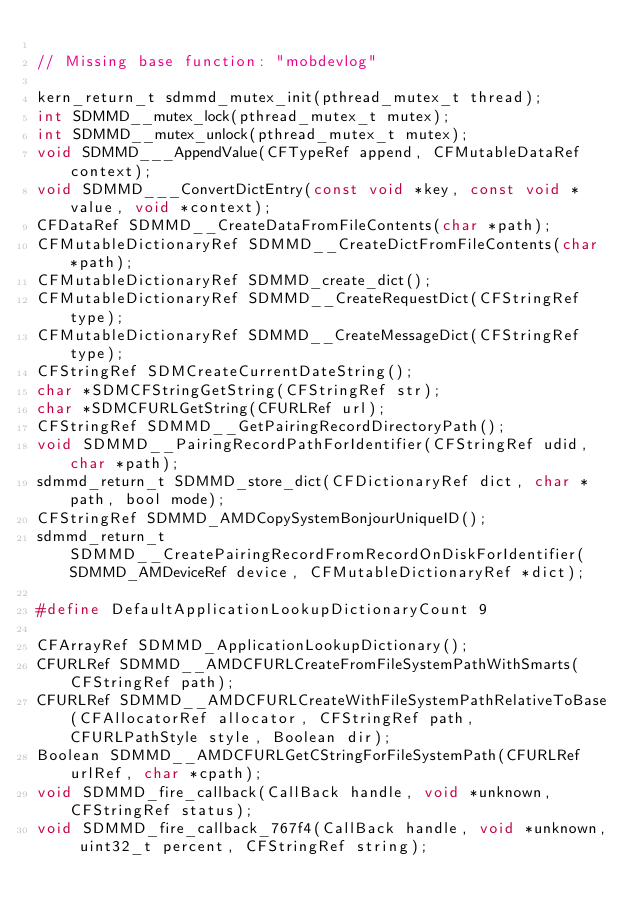<code> <loc_0><loc_0><loc_500><loc_500><_C_>
// Missing base function: "mobdevlog"

kern_return_t sdmmd_mutex_init(pthread_mutex_t thread);
int SDMMD__mutex_lock(pthread_mutex_t mutex);
int SDMMD__mutex_unlock(pthread_mutex_t mutex);
void SDMMD___AppendValue(CFTypeRef append, CFMutableDataRef context);
void SDMMD___ConvertDictEntry(const void *key, const void *value, void *context);
CFDataRef SDMMD__CreateDataFromFileContents(char *path);
CFMutableDictionaryRef SDMMD__CreateDictFromFileContents(char *path);
CFMutableDictionaryRef SDMMD_create_dict();
CFMutableDictionaryRef SDMMD__CreateRequestDict(CFStringRef type);
CFMutableDictionaryRef SDMMD__CreateMessageDict(CFStringRef type);
CFStringRef SDMCreateCurrentDateString();
char *SDMCFStringGetString(CFStringRef str);
char *SDMCFURLGetString(CFURLRef url);
CFStringRef SDMMD__GetPairingRecordDirectoryPath();
void SDMMD__PairingRecordPathForIdentifier(CFStringRef udid, char *path);
sdmmd_return_t SDMMD_store_dict(CFDictionaryRef dict, char *path, bool mode);
CFStringRef SDMMD_AMDCopySystemBonjourUniqueID();
sdmmd_return_t SDMMD__CreatePairingRecordFromRecordOnDiskForIdentifier(SDMMD_AMDeviceRef device, CFMutableDictionaryRef *dict);

#define DefaultApplicationLookupDictionaryCount 9

CFArrayRef SDMMD_ApplicationLookupDictionary();
CFURLRef SDMMD__AMDCFURLCreateFromFileSystemPathWithSmarts(CFStringRef path);
CFURLRef SDMMD__AMDCFURLCreateWithFileSystemPathRelativeToBase(CFAllocatorRef allocator, CFStringRef path, CFURLPathStyle style, Boolean dir);
Boolean SDMMD__AMDCFURLGetCStringForFileSystemPath(CFURLRef urlRef, char *cpath);
void SDMMD_fire_callback(CallBack handle, void *unknown, CFStringRef status);
void SDMMD_fire_callback_767f4(CallBack handle, void *unknown, uint32_t percent, CFStringRef string);</code> 